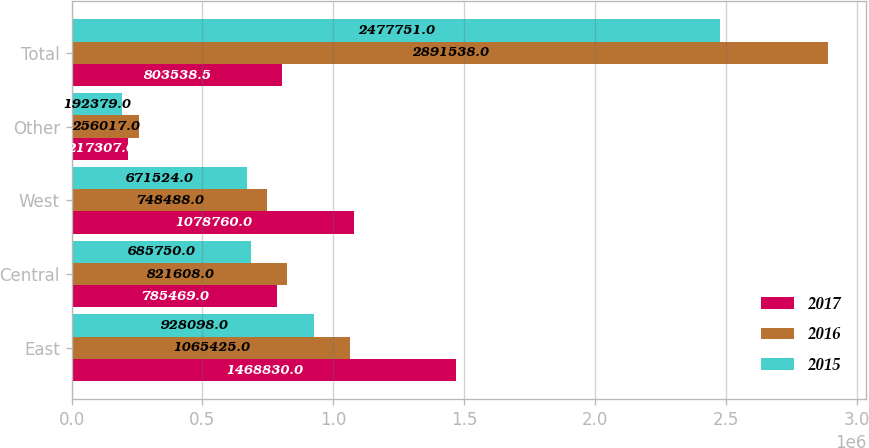Convert chart to OTSL. <chart><loc_0><loc_0><loc_500><loc_500><stacked_bar_chart><ecel><fcel>East<fcel>Central<fcel>West<fcel>Other<fcel>Total<nl><fcel>2017<fcel>1.46883e+06<fcel>785469<fcel>1.07876e+06<fcel>217307<fcel>803538<nl><fcel>2016<fcel>1.06542e+06<fcel>821608<fcel>748488<fcel>256017<fcel>2.89154e+06<nl><fcel>2015<fcel>928098<fcel>685750<fcel>671524<fcel>192379<fcel>2.47775e+06<nl></chart> 